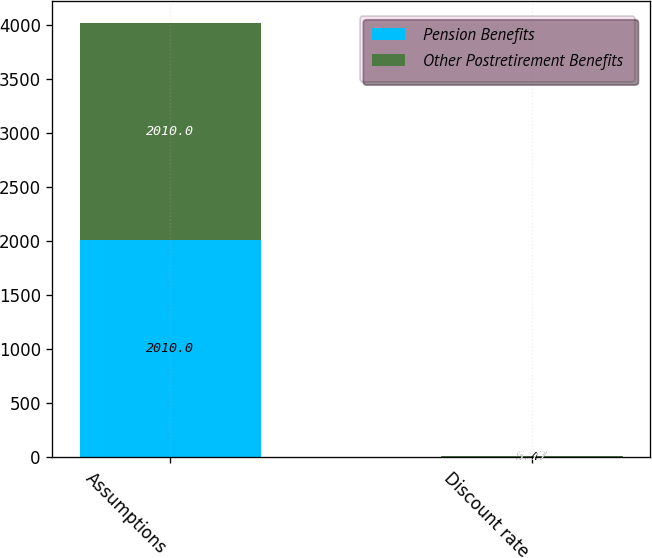Convert chart to OTSL. <chart><loc_0><loc_0><loc_500><loc_500><stacked_bar_chart><ecel><fcel>Assumptions<fcel>Discount rate<nl><fcel>Pension Benefits<fcel>2010<fcel>5.47<nl><fcel>Other Postretirement Benefits<fcel>2010<fcel>5.77<nl></chart> 